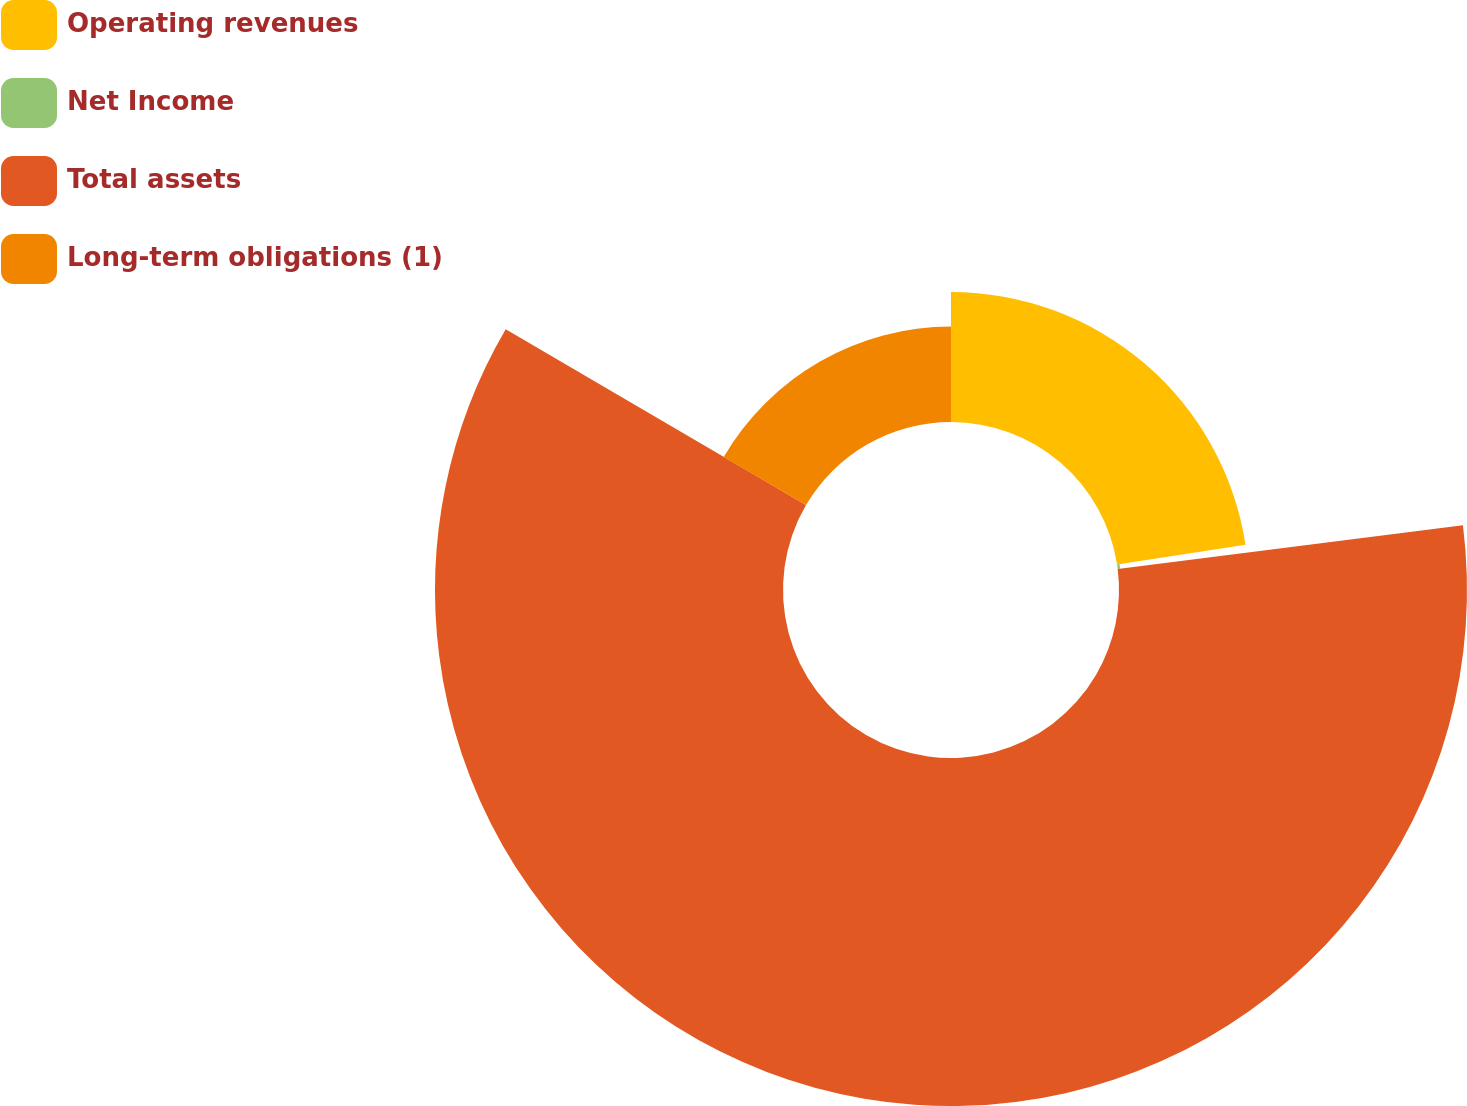<chart> <loc_0><loc_0><loc_500><loc_500><pie_chart><fcel>Operating revenues<fcel>Net Income<fcel>Total assets<fcel>Long-term obligations (1)<nl><fcel>22.57%<fcel>0.43%<fcel>60.43%<fcel>16.57%<nl></chart> 